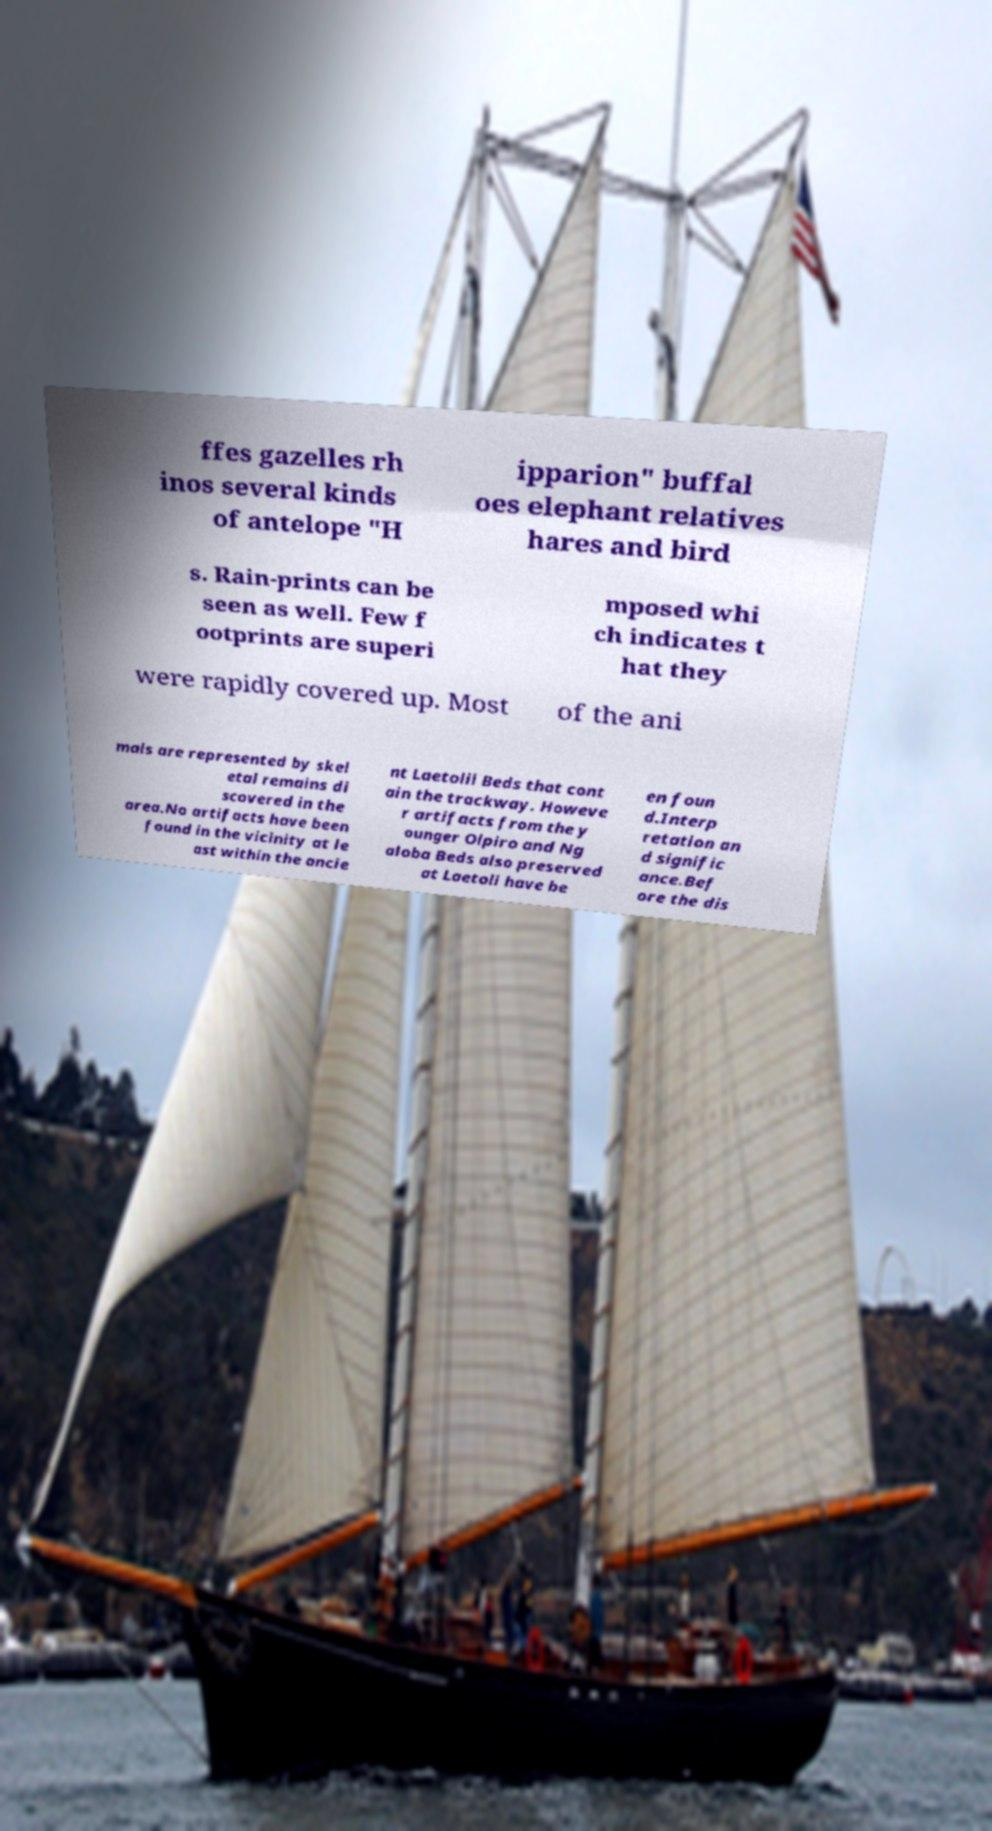What messages or text are displayed in this image? I need them in a readable, typed format. ffes gazelles rh inos several kinds of antelope "H ipparion" buffal oes elephant relatives hares and bird s. Rain-prints can be seen as well. Few f ootprints are superi mposed whi ch indicates t hat they were rapidly covered up. Most of the ani mals are represented by skel etal remains di scovered in the area.No artifacts have been found in the vicinity at le ast within the ancie nt Laetolil Beds that cont ain the trackway. Howeve r artifacts from the y ounger Olpiro and Ng aloba Beds also preserved at Laetoli have be en foun d.Interp retation an d signific ance.Bef ore the dis 